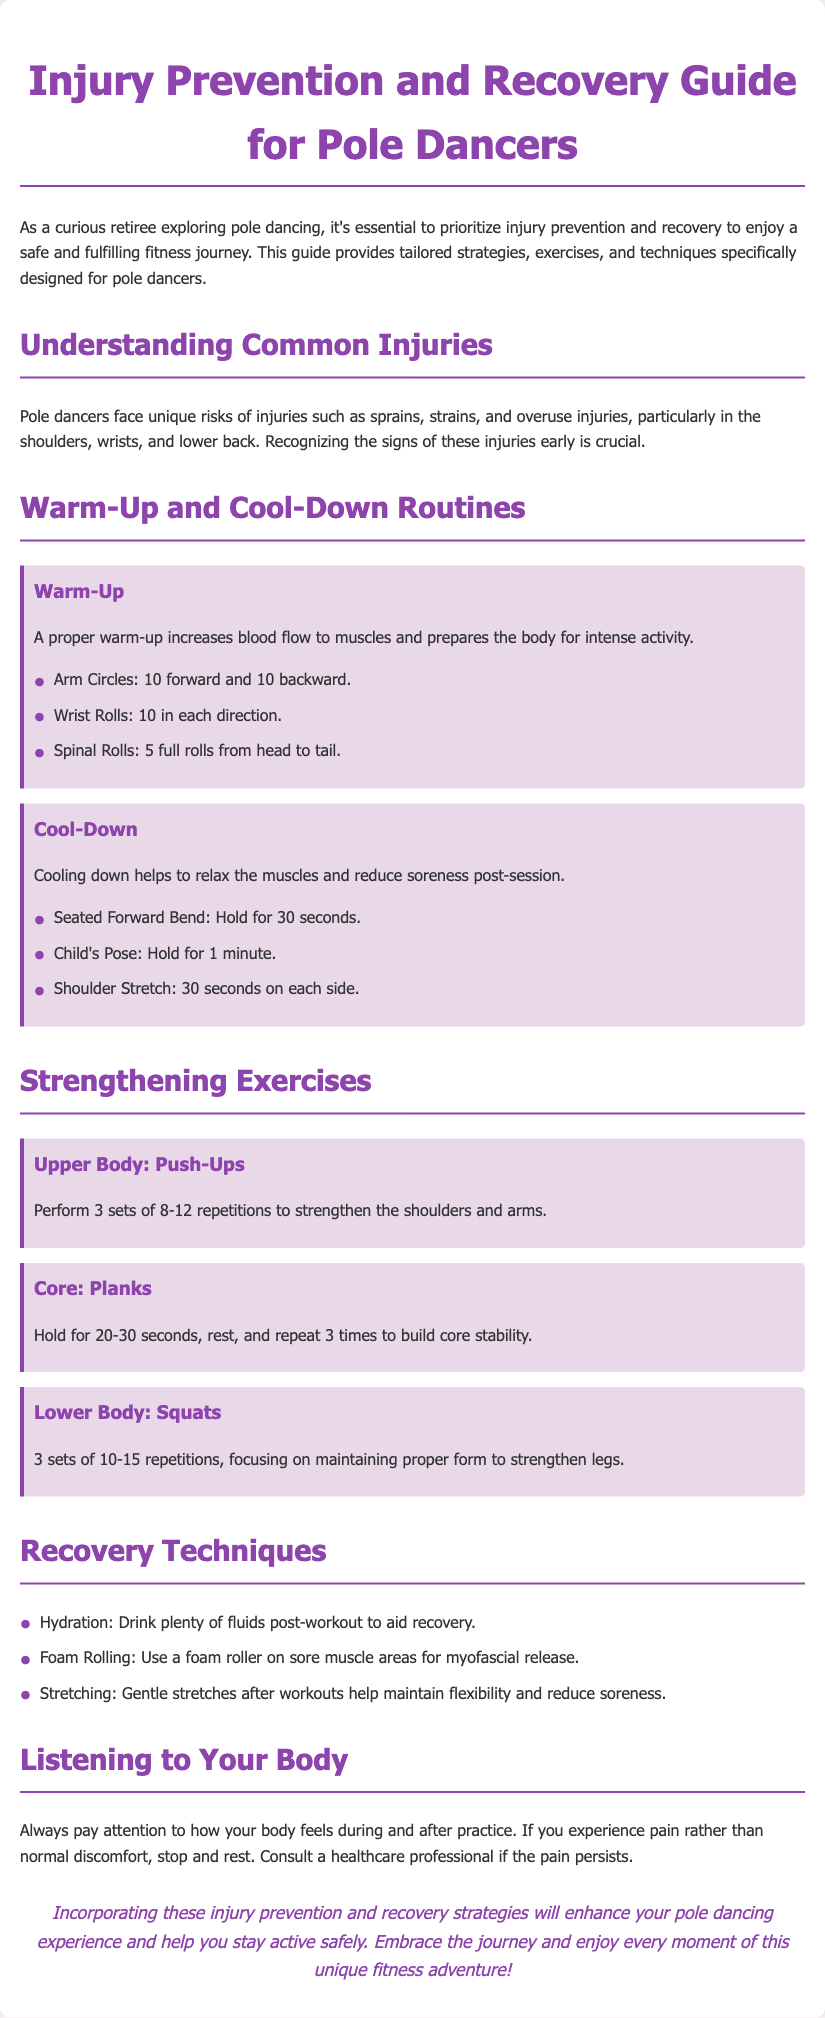What are common injuries faced by pole dancers? The document mentions that pole dancers face unique risks of injuries such as sprains, strains, and overuse injuries, particularly in the shoulders, wrists, and lower back.
Answer: Sprains, strains, overuse injuries How many repetitions are recommended for push-ups? The guideline for push-ups specifies performing 3 sets of 8-12 repetitions to strengthen the shoulders and arms.
Answer: 8-12 repetitions What is the hold duration for the seated forward bend? The document states to hold the seated forward bend for 30 seconds as part of the cool-down routine.
Answer: 30 seconds What is one technique mentioned for aiding recovery? The document lists hydration as one of the techniques to aid recovery after workouts.
Answer: Hydration Why is it important to listen to your body during practice? The document highlights that paying attention to how your body feels helps differentiate between normal discomfort and pain, and suggests consulting a healthcare professional if pain persists.
Answer: To avoid injury How many sets of squats should be performed? The document recommends performing 3 sets of 10-15 repetitions of squats to strengthen the legs.
Answer: 3 sets What should you do if you experience pain rather than normal discomfort? The document advises that if you experience pain, you should stop and rest.
Answer: Stop and rest What is one purpose of a warm-up before pole dancing? The document mentions that a proper warm-up increases blood flow to muscles and prepares the body for intense activity.
Answer: Increases blood flow 